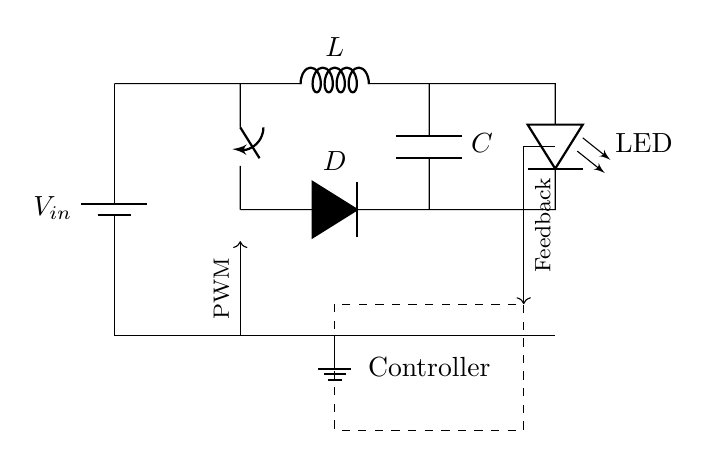What is the input voltage for this circuit? The input voltage is denoted by V subscript in and is shown connected to the battery in the circuit.
Answer: V in What component is used for energy storage in this circuit? The component used for energy storage is an inductor, labeled as L in the circuit.
Answer: L What type of load is connected at the output of the circuit? The load connected is an LED, which is indicated in the circuit diagram with the label LED.
Answer: LED What is the purpose of the diode in this circuit? The diode is used for allowing current to flow in one direction only, which prevents backflow into the switching element.
Answer: Prevent backflow What does PWM stand for in this circuit? PWM stands for Pulse Width Modulation, which is indicated in the circuit as a signal sent to the switching component for regulating power.
Answer: Pulse Width Modulation How is feedback implemented in this circuit? Feedback is implemented with a line that connects the output (after the LED) back to the controller, indicating that the output is being monitored and adjusted.
Answer: Feedback line What is the function of the controller in the circuit? The controller manages the switching of the component based on feedback and PWM signals to regulate the output power to the LED.
Answer: Regulate output power 